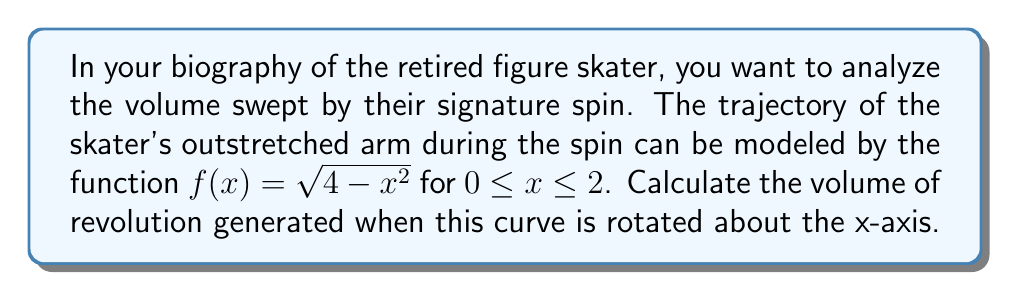Teach me how to tackle this problem. To calculate the volume of revolution, we'll use the disk method:

1) The volume is given by the integral:
   $$V = \pi \int_a^b [f(x)]^2 dx$$

2) In this case, $a=0$, $b=2$, and $f(x) = \sqrt{4-x^2}$

3) Substituting into the formula:
   $$V = \pi \int_0^2 (\sqrt{4-x^2})^2 dx = \pi \int_0^2 (4-x^2) dx$$

4) Expanding the integrand:
   $$V = \pi \int_0^2 (4-x^2) dx = \pi [4x - \frac{x^3}{3}]_0^2$$

5) Evaluating the integral:
   $$V = \pi [(4(2) - \frac{2^3}{3}) - (4(0) - \frac{0^3}{3})]$$
   $$V = \pi [8 - \frac{8}{3} - 0] = \pi [\frac{24}{3} - \frac{8}{3}] = \pi \cdot \frac{16}{3}$$

6) Simplifying:
   $$V = \frac{16\pi}{3} \approx 16.76 \text{ cubic units}$$
Answer: $\frac{16\pi}{3}$ cubic units 